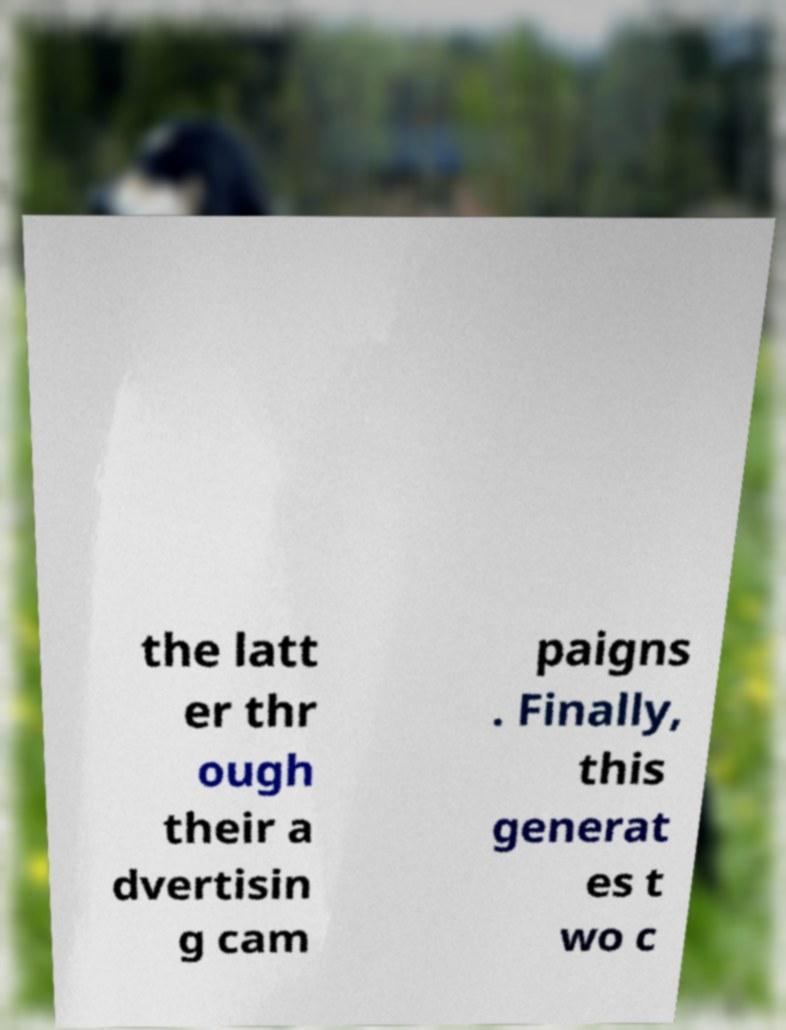For documentation purposes, I need the text within this image transcribed. Could you provide that? the latt er thr ough their a dvertisin g cam paigns . Finally, this generat es t wo c 